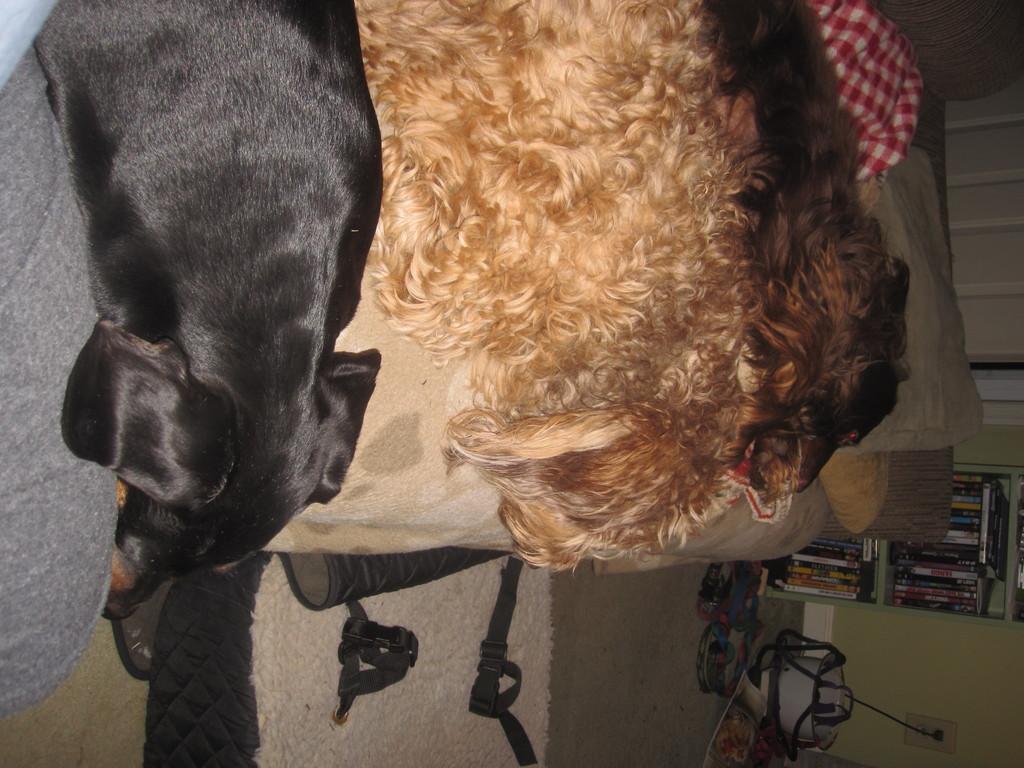Can you describe this image briefly? In the middle of the picture we can see dogs, bed, pillow, blanket, mat and other objects. On the right we can see books, bookshelf, bucket, cable and wall. On the left it might be a person's leg. 